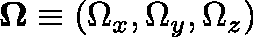<formula> <loc_0><loc_0><loc_500><loc_500>\Omega \equiv ( \Omega _ { x } , \Omega _ { y } , \Omega _ { z } )</formula> 